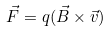Convert formula to latex. <formula><loc_0><loc_0><loc_500><loc_500>\vec { F } = q ( \vec { B } \times \vec { v } )</formula> 